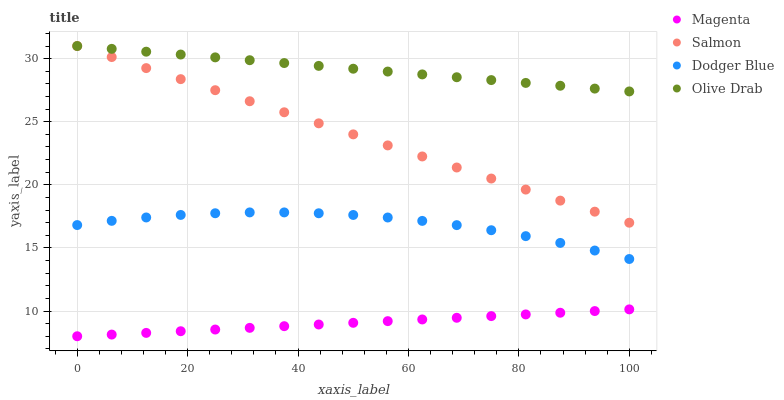Does Magenta have the minimum area under the curve?
Answer yes or no. Yes. Does Olive Drab have the maximum area under the curve?
Answer yes or no. Yes. Does Salmon have the minimum area under the curve?
Answer yes or no. No. Does Salmon have the maximum area under the curve?
Answer yes or no. No. Is Salmon the smoothest?
Answer yes or no. Yes. Is Dodger Blue the roughest?
Answer yes or no. Yes. Is Magenta the smoothest?
Answer yes or no. No. Is Magenta the roughest?
Answer yes or no. No. Does Magenta have the lowest value?
Answer yes or no. Yes. Does Salmon have the lowest value?
Answer yes or no. No. Does Olive Drab have the highest value?
Answer yes or no. Yes. Does Magenta have the highest value?
Answer yes or no. No. Is Dodger Blue less than Salmon?
Answer yes or no. Yes. Is Olive Drab greater than Magenta?
Answer yes or no. Yes. Does Salmon intersect Olive Drab?
Answer yes or no. Yes. Is Salmon less than Olive Drab?
Answer yes or no. No. Is Salmon greater than Olive Drab?
Answer yes or no. No. Does Dodger Blue intersect Salmon?
Answer yes or no. No. 